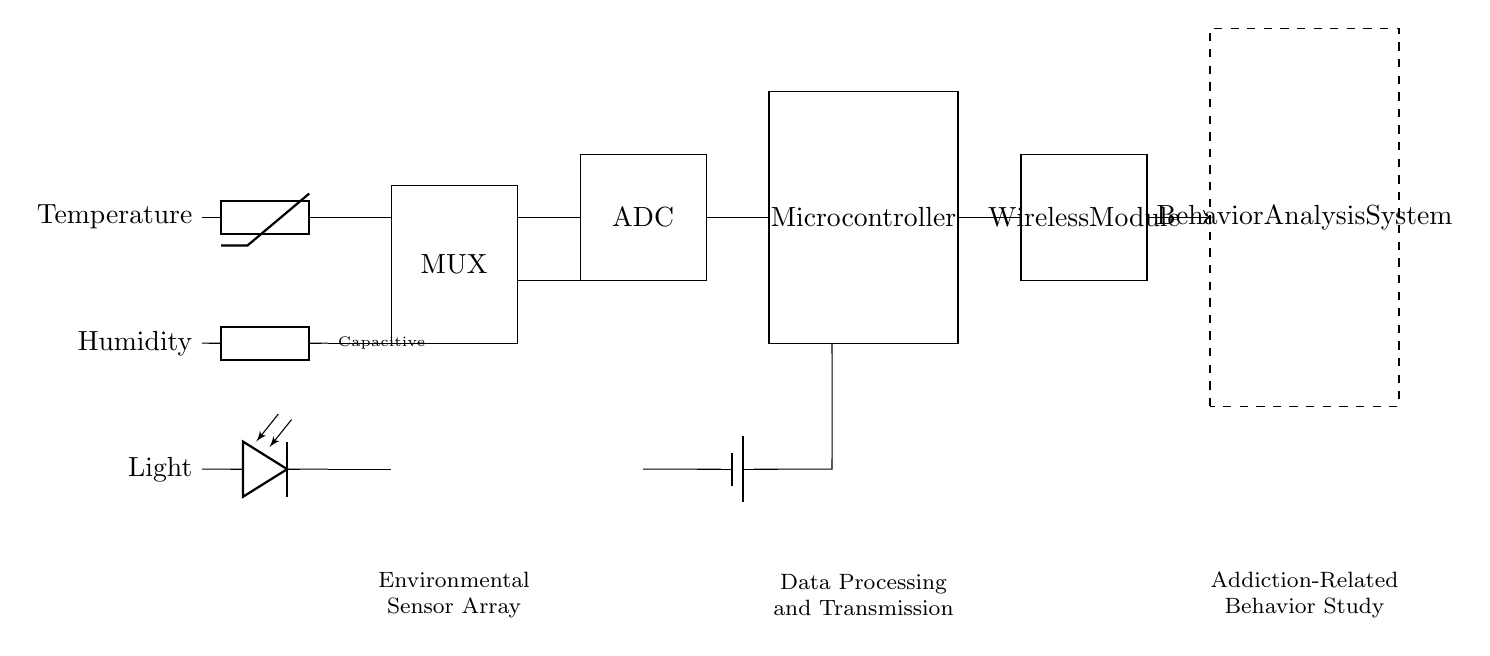What type of sensor is used for measuring temperature? The circuit diagram indicates the use of a thermistor for measuring temperature, as labeled on the left side.
Answer: thermistor What does the MUX in the circuit stand for? The diagram shows a rectangular box labeled "MUX," which represents a multiplexer that combines multiple signals into one output.
Answer: multiplexer How many types of environmental sensors are illustrated in the circuit? The diagram displays three environmental sensors: temperature, humidity, and light, shown in distinct rows.
Answer: three What is the primary function of the microcontroller in this circuit? The microcontroller is responsible for processing the sensor data received from the ADC and managing communication through the wireless module.
Answer: data processing Which component provides power to the circuit? The circuit includes a battery symbol that indicates a power supply for the entire system, providing the necessary voltage and current.
Answer: battery What is the purpose of the behavior analysis system in the circuit? The behavior analysis system is shown as a dashed rectangle on the right side of the diagram; its purpose is to analyze data received and study addiction-related behaviors.
Answer: behavior analysis How are the sensor signals directed to the ADC? The connections from the sensors (thermistor, generic humidity sensor, and photodiode) directly lead to the inputs of the multiplexer, which forwards the selected signal to the ADC.
Answer: multiplexer connection 